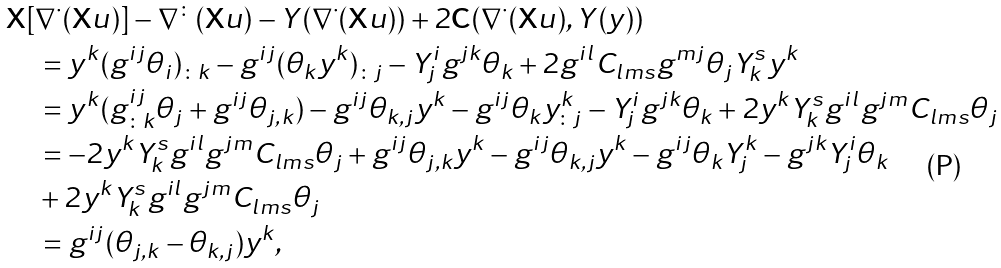Convert formula to latex. <formula><loc_0><loc_0><loc_500><loc_500>& \mathbf X [ \nabla ^ { \cdot } ( \mathbf X u ) ] - \nabla ^ { \colon } ( \mathbf X u ) - Y ( \nabla ^ { \cdot } ( \mathbf X u ) ) + 2 \mathbf C ( \nabla ^ { \cdot } ( \mathbf X u ) , Y ( y ) ) \\ & \quad = y ^ { k } ( g ^ { i j } \theta _ { i } ) _ { \colon k } - g ^ { i j } ( \theta _ { k } y ^ { k } ) _ { \colon j } - Y ^ { i } _ { j } g ^ { j k } \theta _ { k } + 2 g ^ { i l } C _ { l m s } g ^ { m j } \theta _ { j } Y ^ { s } _ { k } y ^ { k } \\ & \quad = y ^ { k } ( g ^ { i j } _ { \colon k } \theta _ { j } + g ^ { i j } \theta _ { j , k } ) - g ^ { i j } \theta _ { k , j } y ^ { k } - g ^ { i j } \theta _ { k } y ^ { k } _ { \colon j } - Y ^ { i } _ { j } g ^ { j k } \theta _ { k } + 2 y ^ { k } Y ^ { s } _ { k } g ^ { i l } g ^ { j m } C _ { l m s } \theta _ { j } \\ & \quad = - 2 y ^ { k } Y ^ { s } _ { k } g ^ { i l } g ^ { j m } C _ { l m s } \theta _ { j } + g ^ { i j } \theta _ { j , k } y ^ { k } - g ^ { i j } \theta _ { k , j } y ^ { k } - g ^ { i j } \theta _ { k } Y ^ { k } _ { j } - g ^ { j k } Y ^ { i } _ { j } \theta _ { k } \\ & \quad + 2 y ^ { k } Y ^ { s } _ { k } g ^ { i l } g ^ { j m } C _ { l m s } \theta _ { j } \\ & \quad = g ^ { i j } ( \theta _ { j , k } - \theta _ { k , j } ) y ^ { k } ,</formula> 